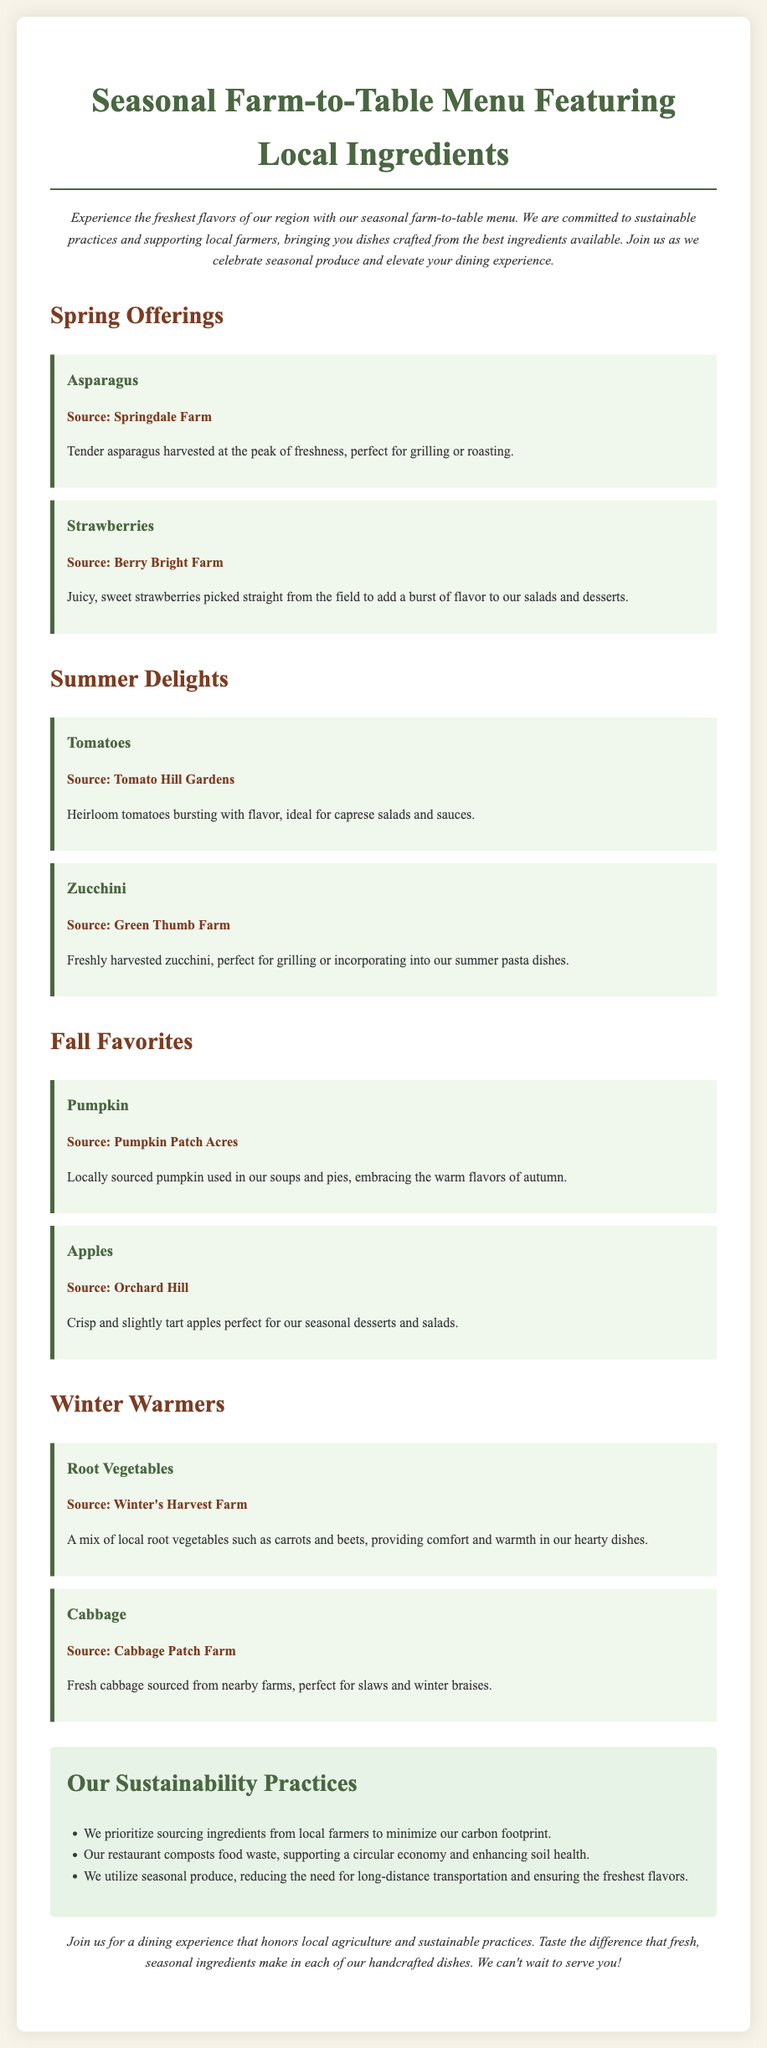What is the title of the menu? The title of the menu is provided at the beginning of the document.
Answer: Seasonal Farm-to-Table Menu Featuring Local Ingredients Which farm supplies the strawberries? The document lists the sources of each ingredient.
Answer: Berry Bright Farm Name one of the winter vegetables mentioned. The document categorizes ingredients by season.
Answer: Root Vegetables How many Spring offerings are listed? The document outlines the seasonal offerings.
Answer: 2 What is one of the sustainability practices mentioned? The sustainability section details practices implemented by the restaurant.
Answer: Composting food waste Which ingredient is highlighted for summer dishes? The summer section specifies key ingredients for that season.
Answer: Tomatoes What type of menu is this document showcasing? The document's introduction describes the nature of the menu.
Answer: Farm-to-Table Menu Where is the pumpkin sourced from? Each ingredient includes its respective source in the document.
Answer: Pumpkin Patch Acres 